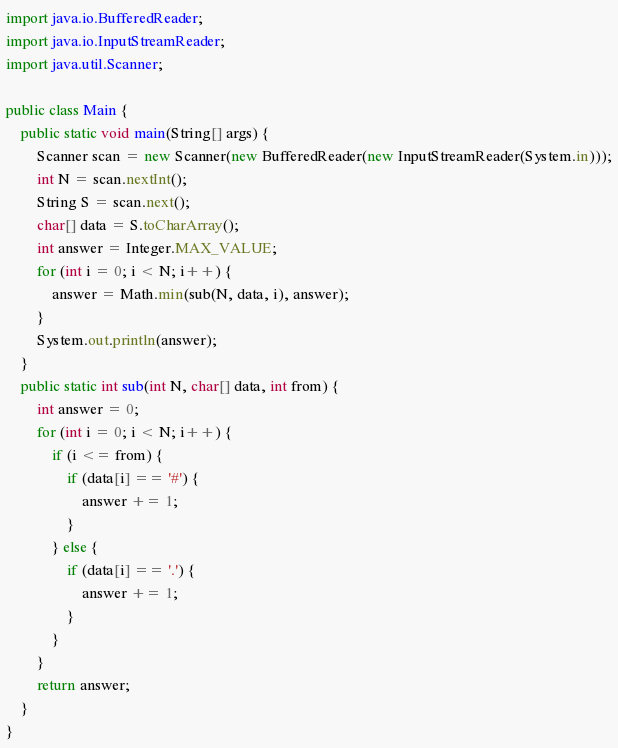<code> <loc_0><loc_0><loc_500><loc_500><_Java_>import java.io.BufferedReader;
import java.io.InputStreamReader;
import java.util.Scanner;

public class Main {
    public static void main(String[] args) {
        Scanner scan = new Scanner(new BufferedReader(new InputStreamReader(System.in)));
        int N = scan.nextInt();
        String S = scan.next();
        char[] data = S.toCharArray();
        int answer = Integer.MAX_VALUE;
        for (int i = 0; i < N; i++) {
            answer = Math.min(sub(N, data, i), answer);
        }
        System.out.println(answer);
    }
    public static int sub(int N, char[] data, int from) {
        int answer = 0;
        for (int i = 0; i < N; i++) {
            if (i <= from) {
                if (data[i] == '#') {
                    answer += 1;
                }
            } else {
                if (data[i] == '.') {
                    answer += 1;
                }
            }
        }
        return answer;
    }
}
</code> 